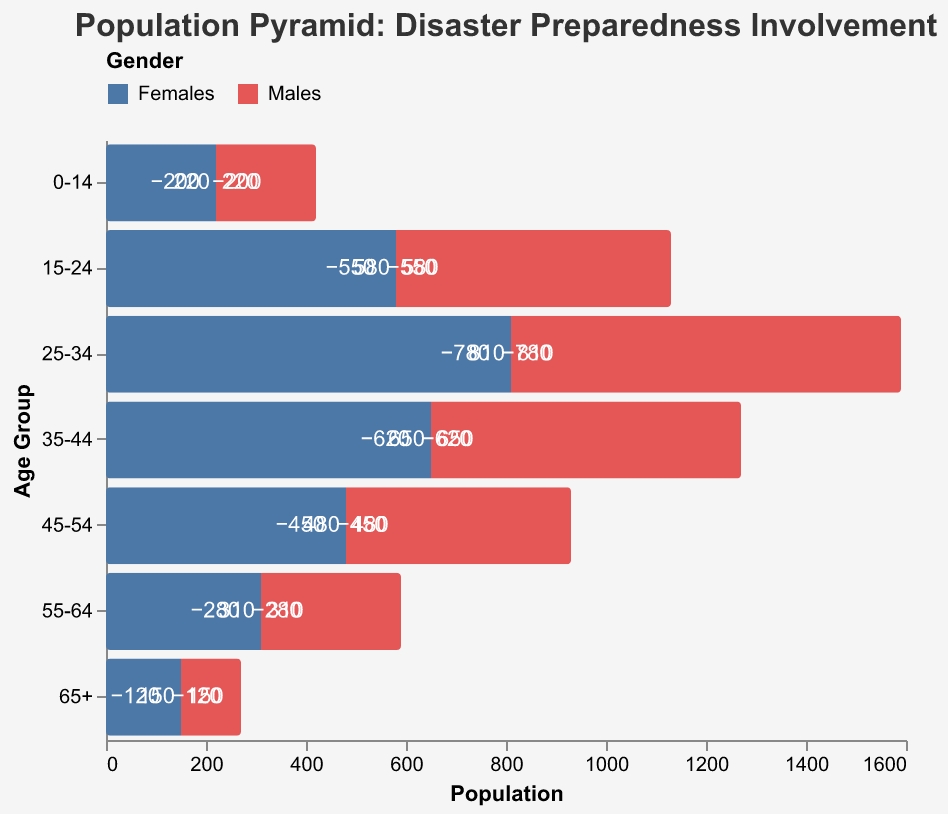What is the title of the figure? The title is located at the top of the figure and is usually larger in font size compared to other text elements.
Answer: Population Pyramid: Disaster Preparedness Involvement What is the age group with the highest female population involved in disaster preparedness initiatives? To find the age group with the highest female population, look for the group with the largest bar on the female (right) side.
Answer: 25-34 What is the difference between the male and female populations in the 45-54 age group? To determine this, refer to the bars representing males and females in the 45-54 age group and calculate the difference by subtracting male from female values. \( 480 - 450 \) = 30
Answer: 30 Which age group has more females compared to males in disaster preparedness initiatives? Compare the lengths of the bars for each age group to see where the female (right) bar is longer than the male (left) bar.
Answer: All age groups have more females compared to males What is the total number of males involved in disaster preparedness initiatives? Add up the male population values for all age groups. \( 120 + 280 + 450 + 620 + 780 + 550 + 200 \) = 3000
Answer: 3000 How many females are there in the age group 15-24? Locate the bar representing females in the 15-24 age group and read the value from the figure.
Answer: 580 What is the ratio of the male population in the 25-34 age group to the male population in the 65+ age group? Determine the values for both age groups (780 for 25-34 and 120 for 65+), then divide the larger number by the smaller number. \( \frac{780}{120} \) = 6.5
Answer: 6.5 